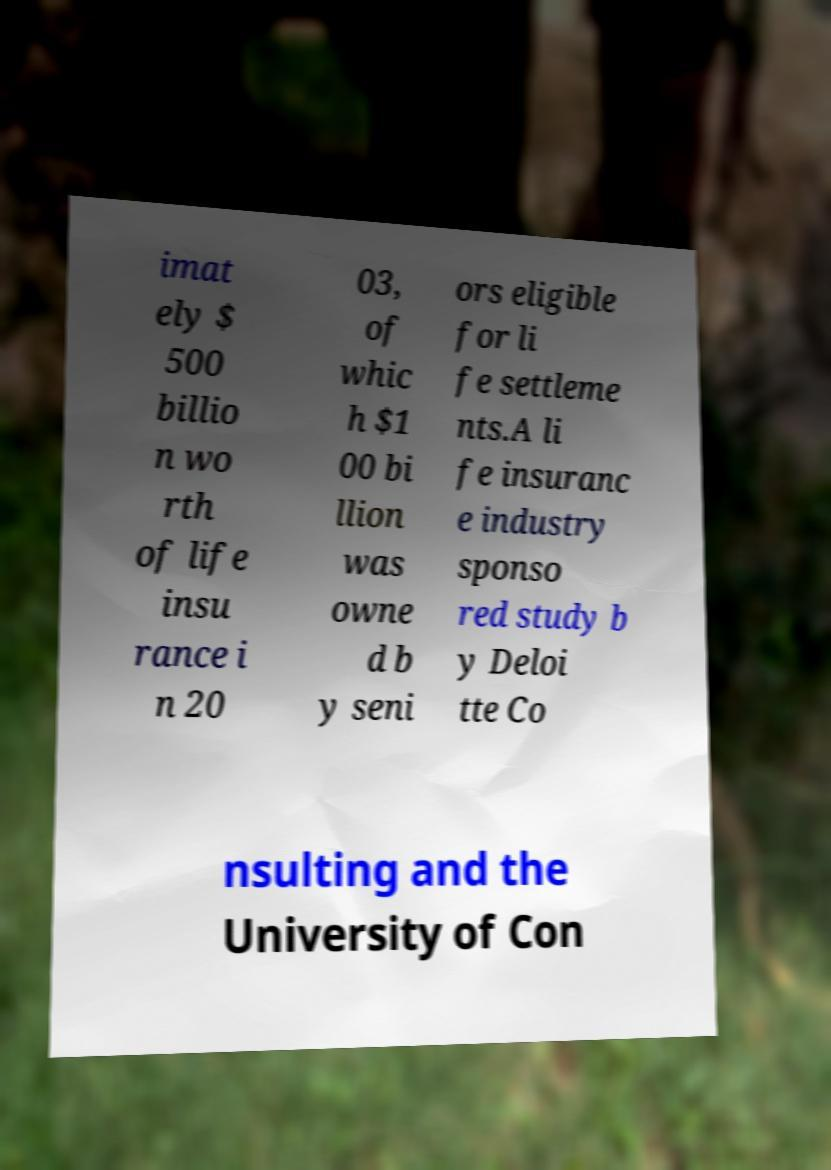Please identify and transcribe the text found in this image. imat ely $ 500 billio n wo rth of life insu rance i n 20 03, of whic h $1 00 bi llion was owne d b y seni ors eligible for li fe settleme nts.A li fe insuranc e industry sponso red study b y Deloi tte Co nsulting and the University of Con 